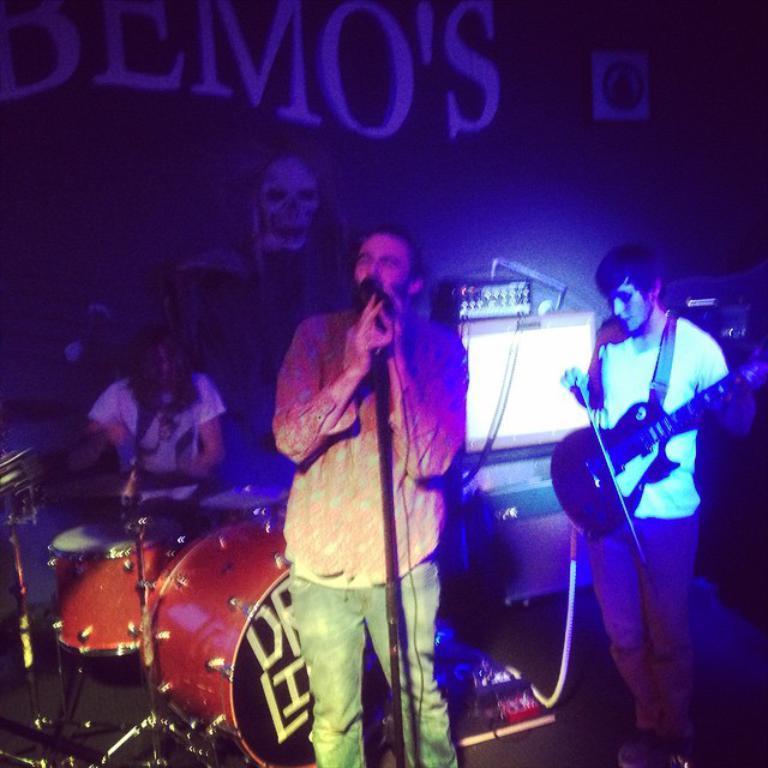Could you give a brief overview of what you see in this image? 2 persons are standing. the person at the right is holding guitar. the person at the center is singing. behind them there are drums and a person is playing that. behind that there is a wall on which bemo's is written. 